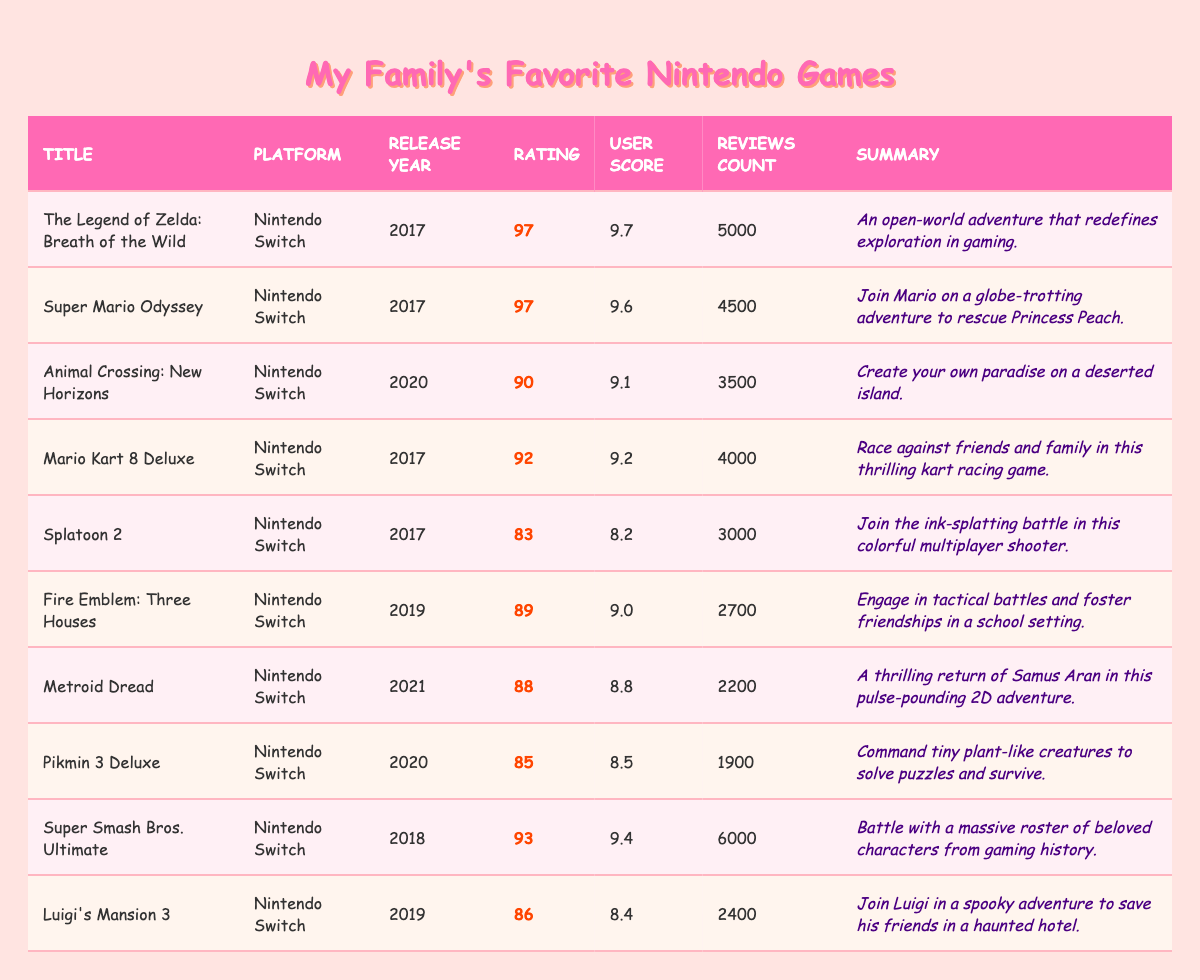What is the title with the highest rating? The ratings of the titles are listed, and "The Legend of Zelda: Breath of the Wild" has the highest rating at 97.
Answer: The Legend of Zelda: Breath of the Wild How many reviews did "Fire Emblem: Three Houses" receive? "Fire Emblem: Three Houses" has a reviews count of 2700 as listed in the table.
Answer: 2700 What is the user score for "Animal Crossing: New Horizons"? The table indicates that "Animal Crossing: New Horizons" has a user score of 9.1.
Answer: 9.1 Which game has a release year of 2021? Based on the table, "Metroid Dread" is the only game listed that was released in 2021.
Answer: Metroid Dread What is the average rating of all the Nintendo titles listed? To find the average rating, add all the ratings (97 + 97 + 90 + 92 + 83 + 89 + 88 + 85 + 93 + 86 = 909) and divide by the number of titles (10), giving an average of 90.9.
Answer: 90.9 Is "Super Mario Odyssey" rated higher than "Luigi's Mansion 3"? "Super Mario Odyssey" has a rating of 97, while "Luigi's Mansion 3" has a rating of 86, confirming that Super Mario Odyssey is rated higher.
Answer: Yes What is the total number of user scores available for all the games? Adding the user scores of all titles (9.7 + 9.6 + 9.1 + 9.2 + 8.2 + 9.0 + 8.8 + 8.5 + 9.4 + 8.4 = 88.7) indicates that the total user score is 88.7 across all titles.
Answer: 88.7 Which title has the least number of reviews? The title with the least reviews is "Pikmin 3 Deluxe," which has a count of 1900 reviews.
Answer: Pikmin 3 Deluxe How many total reviews were counted for games with a rating above 90? The games with a rating above 90 are "The Legend of Zelda: Breath of the Wild," "Super Mario Odyssey," "Mario Kart 8 Deluxe," "Super Smash Bros. Ultimate," totaling their reviews: (5000 + 4500 + 4000 + 6000 = 19500).
Answer: 19500 Which game has a higher rating, "Metroid Dread" or "Pikmin 3 Deluxe"? "Metroid Dread" has a rating of 88, while "Pikmin 3 Deluxe" has a rating of 85. Thus, Metroid Dread has a higher rating.
Answer: Metroid Dread 